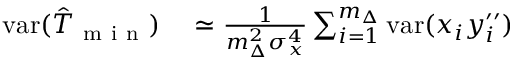<formula> <loc_0><loc_0><loc_500><loc_500>\begin{array} { r l } { v a r ( \hat { T } _ { m i n } ) } & \simeq \frac { 1 } { m _ { \Delta } ^ { 2 } \sigma _ { x } ^ { 4 } } \sum _ { i = 1 } ^ { m _ { \Delta } } v a r ( x _ { i } y _ { i } ^ { \prime \prime } ) } \end{array}</formula> 